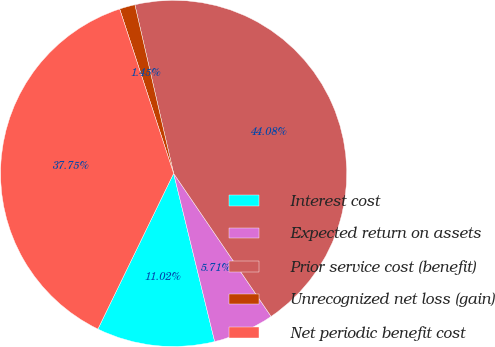Convert chart. <chart><loc_0><loc_0><loc_500><loc_500><pie_chart><fcel>Interest cost<fcel>Expected return on assets<fcel>Prior service cost (benefit)<fcel>Unrecognized net loss (gain)<fcel>Net periodic benefit cost<nl><fcel>11.02%<fcel>5.71%<fcel>44.08%<fcel>1.45%<fcel>37.75%<nl></chart> 